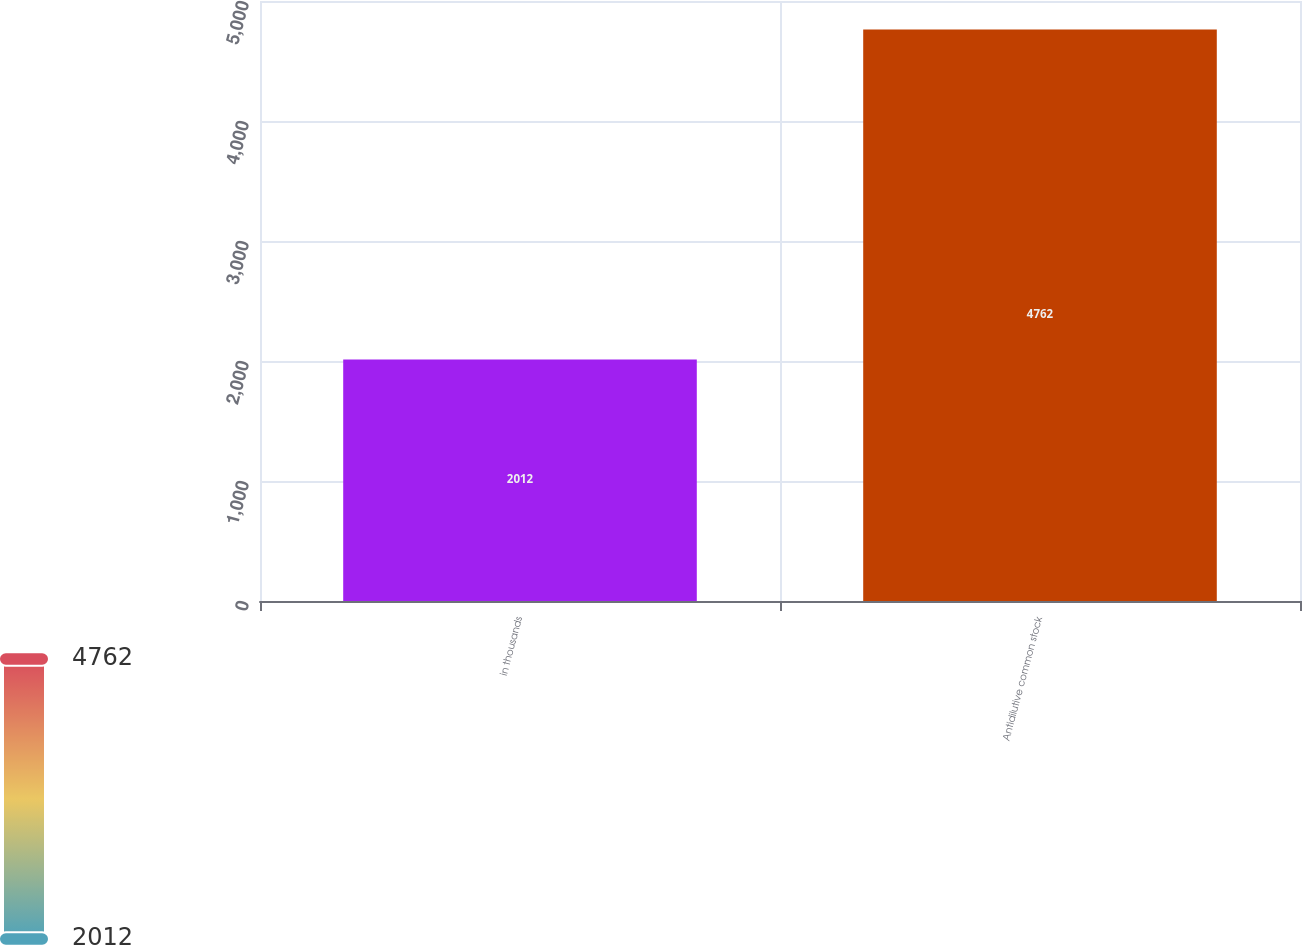<chart> <loc_0><loc_0><loc_500><loc_500><bar_chart><fcel>in thousands<fcel>Antidilutive common stock<nl><fcel>2012<fcel>4762<nl></chart> 